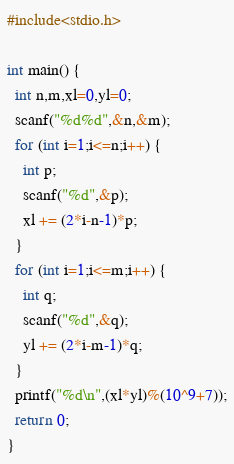<code> <loc_0><loc_0><loc_500><loc_500><_C_>#include<stdio.h>

int main() {
  int n,m,xl=0,yl=0;
  scanf("%d%d",&n,&m);
  for (int i=1;i<=n;i++) {
    int p;
    scanf("%d",&p);
    xl += (2*i-n-1)*p;
  }
  for (int i=1;i<=m;i++) {
    int q;
    scanf("%d",&q);
    yl += (2*i-m-1)*q;
  }
  printf("%d\n",(xl*yl)%(10^9+7));
  return 0;
}</code> 